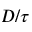Convert formula to latex. <formula><loc_0><loc_0><loc_500><loc_500>D / \tau</formula> 